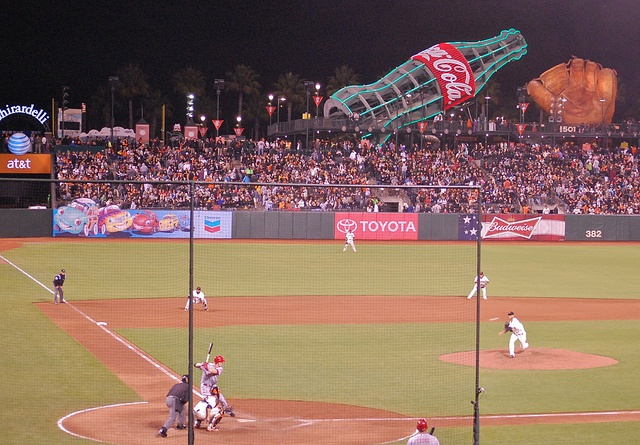Describe the objects in this image and their specific colors. I can see bottle in black, gray, and darkgray tones, people in black, purple, and gray tones, people in black, white, lightpink, brown, and maroon tones, people in black, lavender, lightpink, pink, and violet tones, and people in black, white, lightpink, brown, and darkgray tones in this image. 